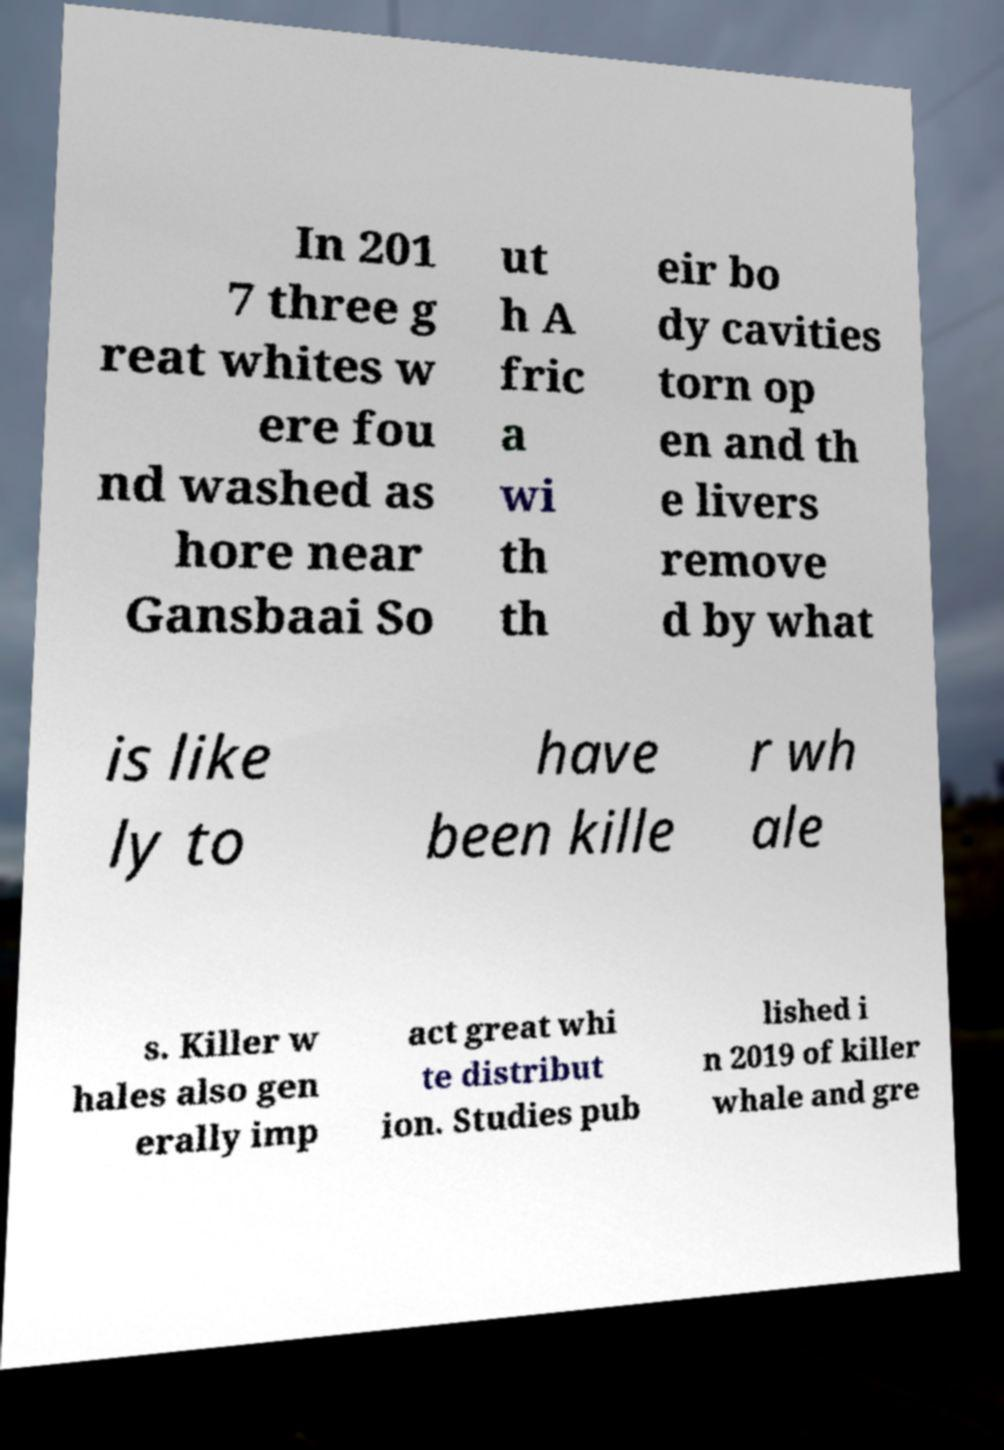There's text embedded in this image that I need extracted. Can you transcribe it verbatim? In 201 7 three g reat whites w ere fou nd washed as hore near Gansbaai So ut h A fric a wi th th eir bo dy cavities torn op en and th e livers remove d by what is like ly to have been kille r wh ale s. Killer w hales also gen erally imp act great whi te distribut ion. Studies pub lished i n 2019 of killer whale and gre 